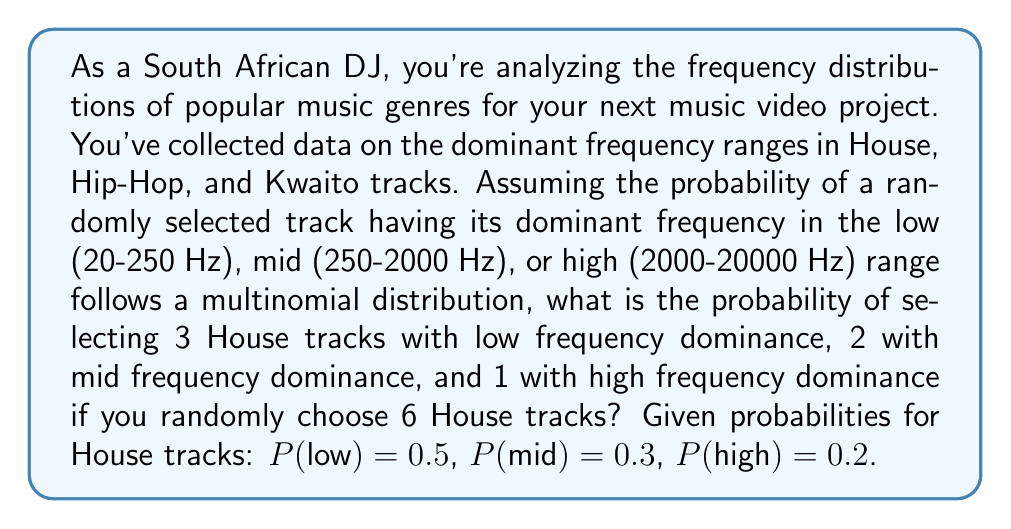Can you solve this math problem? To solve this problem, we'll use the multinomial probability distribution formula:

$$P(X_1 = x_1, X_2 = x_2, ..., X_k = x_k) = \frac{n!}{x_1! x_2! ... x_k!} p_1^{x_1} p_2^{x_2} ... p_k^{x_k}$$

Where:
- $n$ is the total number of trials (tracks selected)
- $x_i$ is the number of occurrences of each outcome
- $p_i$ is the probability of each outcome

Given:
- $n = 6$ (total tracks selected)
- $x_1 = 3$ (low frequency tracks)
- $x_2 = 2$ (mid frequency tracks)
- $x_3 = 1$ (high frequency track)
- $p_1 = 0.5$ (probability of low frequency)
- $p_2 = 0.3$ (probability of mid frequency)
- $p_3 = 0.2$ (probability of high frequency)

Step 1: Calculate the factorial term
$$\frac{n!}{x_1! x_2! x_3!} = \frac{6!}{3! 2! 1!} = \frac{720}{12} = 60$$

Step 2: Calculate the probability term
$$p_1^{x_1} p_2^{x_2} p_3^{x_3} = 0.5^3 \cdot 0.3^2 \cdot 0.2^1 = 0.00225$$

Step 3: Multiply the factorial and probability terms
$$60 \cdot 0.00225 = 0.135$$

Therefore, the probability of selecting 3 low, 2 mid, and 1 high frequency dominant House tracks out of 6 randomly chosen tracks is 0.135 or 13.5%.
Answer: 0.135 